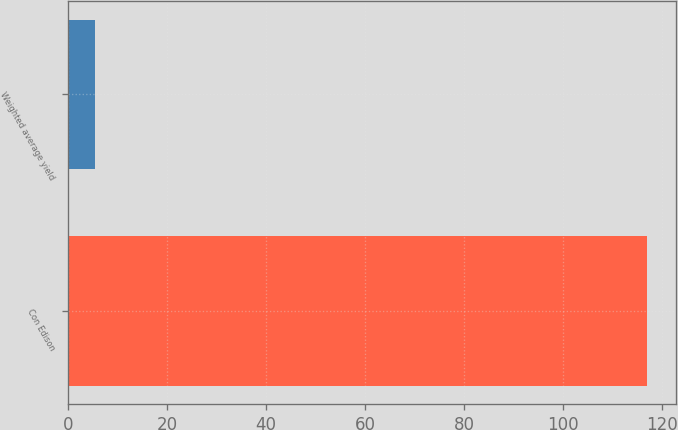Convert chart. <chart><loc_0><loc_0><loc_500><loc_500><bar_chart><fcel>Con Edison<fcel>Weighted average yield<nl><fcel>117<fcel>5.4<nl></chart> 